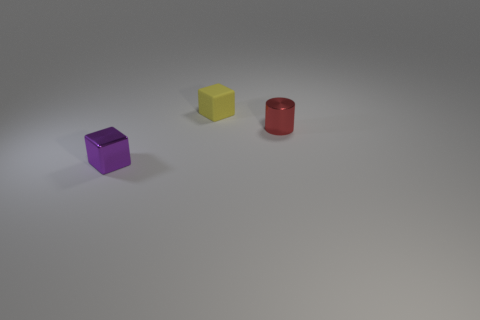There is a cube that is behind the purple thing; is its size the same as the tiny red cylinder?
Provide a short and direct response. Yes. Is the number of red shiny things in front of the small red shiny thing greater than the number of tiny brown metallic blocks?
Your response must be concise. No. Is the purple thing the same shape as the tiny red object?
Provide a short and direct response. No. The red metallic cylinder is what size?
Your response must be concise. Small. Is the number of tiny purple blocks that are right of the tiny purple block greater than the number of tiny metal cubes that are behind the red cylinder?
Provide a short and direct response. No. Are there any purple shiny cubes to the left of the tiny metallic cube?
Make the answer very short. No. Are there any other yellow objects that have the same size as the rubber thing?
Your answer should be compact. No. What color is the cube that is made of the same material as the tiny cylinder?
Your answer should be very brief. Purple. Are there an equal number of red shiny cylinders and big brown rubber objects?
Your answer should be compact. No. What is the purple block made of?
Make the answer very short. Metal. 